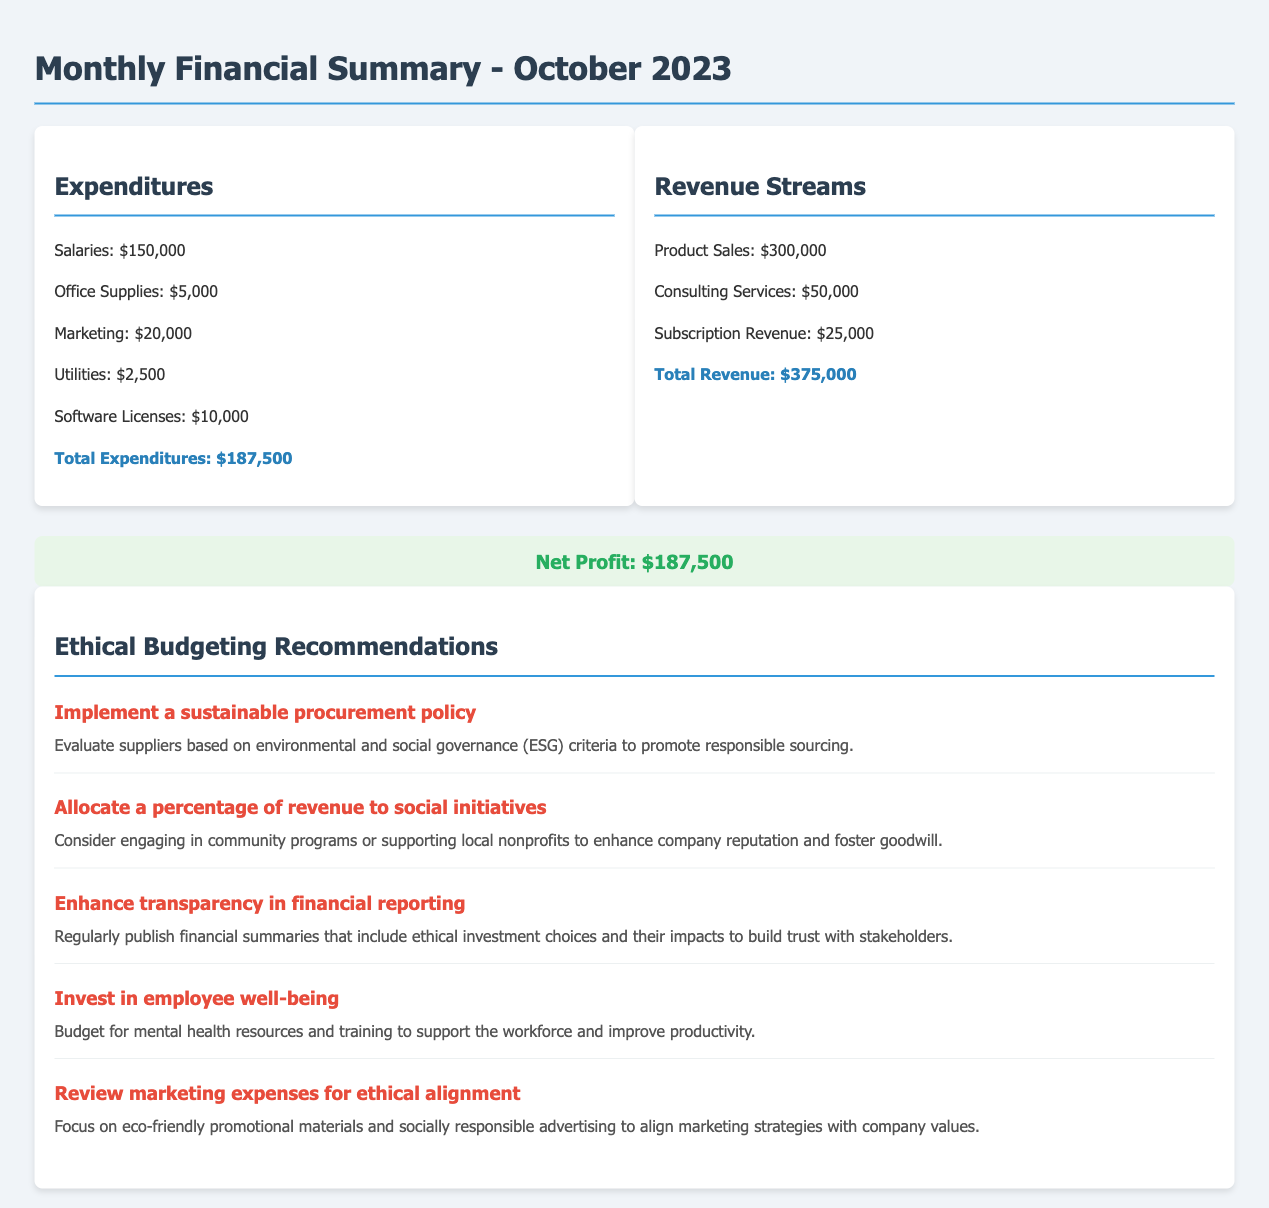What is the total expenditures? The total expenditures are calculated by adding all expenditure categories together, which equals $150,000 + $5,000 + $20,000 + $2,500 + $10,000.
Answer: $187,500 What is the total revenue? The total revenue is calculated by summing all revenue streams, which equals $300,000 + $50,000 + $25,000.
Answer: $375,000 What is the net profit? The net profit is determined by subtracting total expenditures from total revenue, resulting in $375,000 - $187,500.
Answer: $187,500 What is one ethical budgeting recommendation? This asks for any of the ethical budgeting recommendations that can be found in the document, which includes initiatives like supporting social programs or supplier evaluation.
Answer: Implement a sustainable procurement policy How much was spent on marketing? The specific expenditure for marketing is explicitly mentioned in the financial summary.
Answer: $20,000 How much revenue did consulting services bring in? The amount earned from consulting services is stated in the revenue section of the document.
Answer: $50,000 How many recommendations for ethical budgeting are listed? The document provides a structured list of recommendations that can be counted to give this answer.
Answer: Five What criterion should suppliers be evaluated on? This refers to the specific criteria mentioned in the recommendation related to suppliers.
Answer: Environmental and social governance What should be included in financial summaries for transparency? This refers to the elements that should be part of financial summaries to improve transparency according to one of the recommendations.
Answer: Ethical investment choices and their impacts 